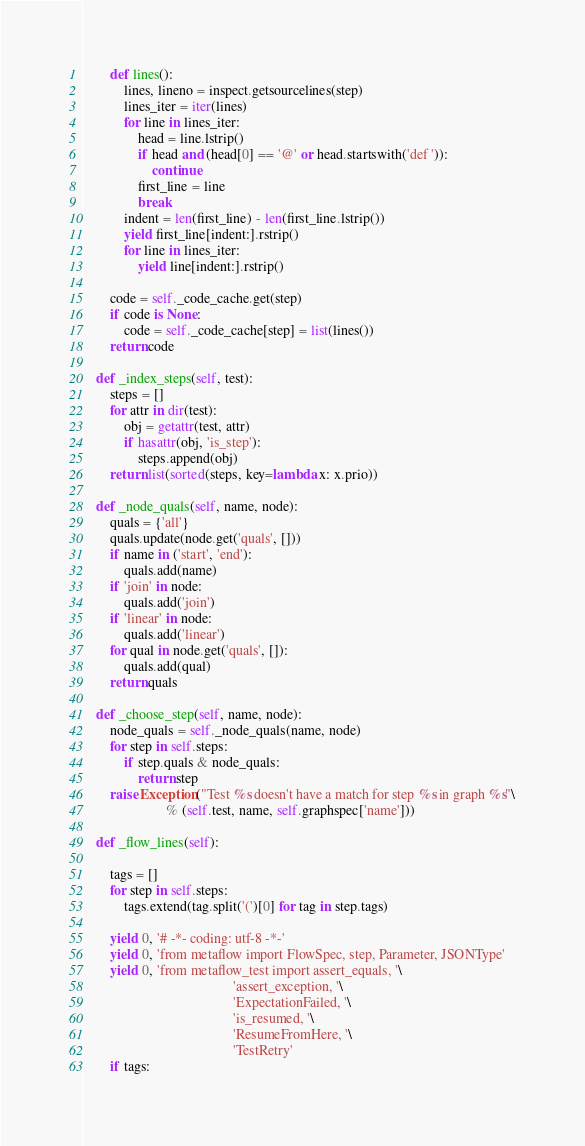Convert code to text. <code><loc_0><loc_0><loc_500><loc_500><_Python_>        def lines():
            lines, lineno = inspect.getsourcelines(step)
            lines_iter = iter(lines)
            for line in lines_iter:
                head = line.lstrip()
                if head and (head[0] == '@' or head.startswith('def ')):
                    continue
                first_line = line
                break
            indent = len(first_line) - len(first_line.lstrip())
            yield first_line[indent:].rstrip()
            for line in lines_iter:
                yield line[indent:].rstrip()

        code = self._code_cache.get(step)
        if code is None:
            code = self._code_cache[step] = list(lines())
        return code

    def _index_steps(self, test):
        steps = []
        for attr in dir(test):
            obj = getattr(test, attr)
            if hasattr(obj, 'is_step'):
                steps.append(obj)
        return list(sorted(steps, key=lambda x: x.prio))

    def _node_quals(self, name, node):
        quals = {'all'}
        quals.update(node.get('quals', []))
        if name in ('start', 'end'):
            quals.add(name)
        if 'join' in node:
            quals.add('join')
        if 'linear' in node:
            quals.add('linear')
        for qual in node.get('quals', []):
            quals.add(qual)
        return quals

    def _choose_step(self, name, node):
        node_quals = self._node_quals(name, node)
        for step in self.steps:
            if step.quals & node_quals:
                return step
        raise Exception("Test %s doesn't have a match for step %s in graph %s"\
                        % (self.test, name, self.graphspec['name']))

    def _flow_lines(self):

        tags = []
        for step in self.steps:
            tags.extend(tag.split('(')[0] for tag in step.tags)

        yield 0, '# -*- coding: utf-8 -*-'
        yield 0, 'from metaflow import FlowSpec, step, Parameter, JSONType'
        yield 0, 'from metaflow_test import assert_equals, '\
                                           'assert_exception, '\
                                           'ExpectationFailed, '\
                                           'is_resumed, '\
                                           'ResumeFromHere, '\
                                           'TestRetry'
        if tags:</code> 